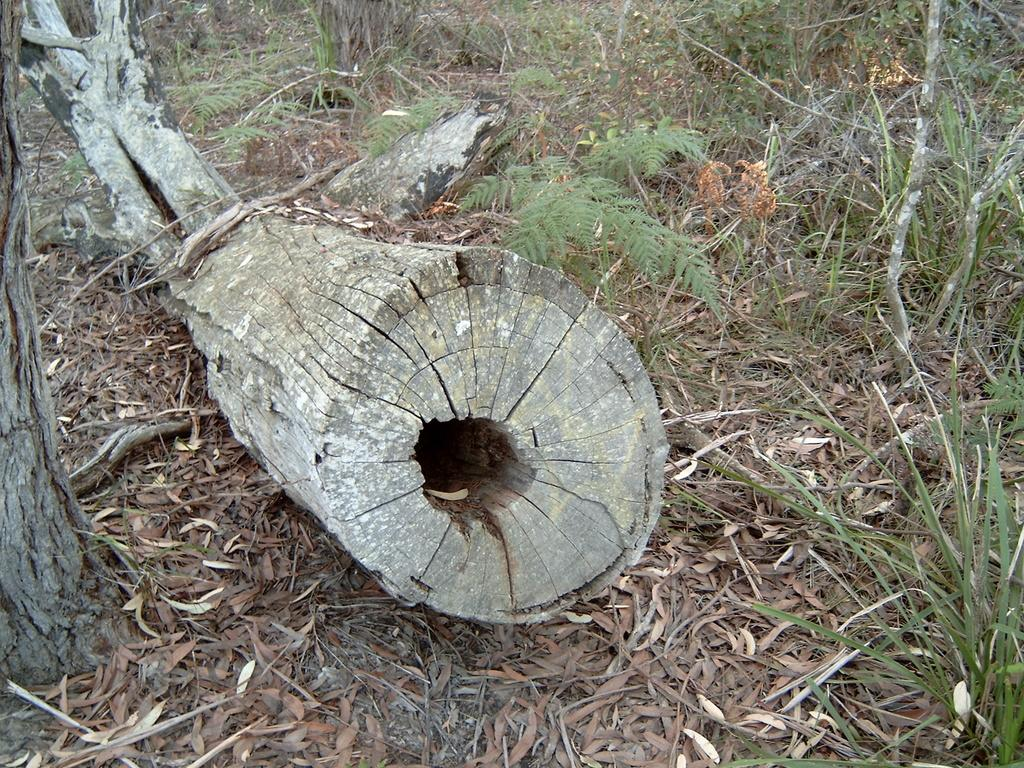What object is located on the ground in the foreground of the image? There is a trunk on the ground in the foreground of the image. What type of vegetation can be seen in the background of the image? There is grass in the background of the image. What else is present in the background of the image? There are sticks in the background of the image. Where is the pocket located in the image? There is no pocket present in the image. Can you see a guitar in the image? There is no guitar present in the image. 